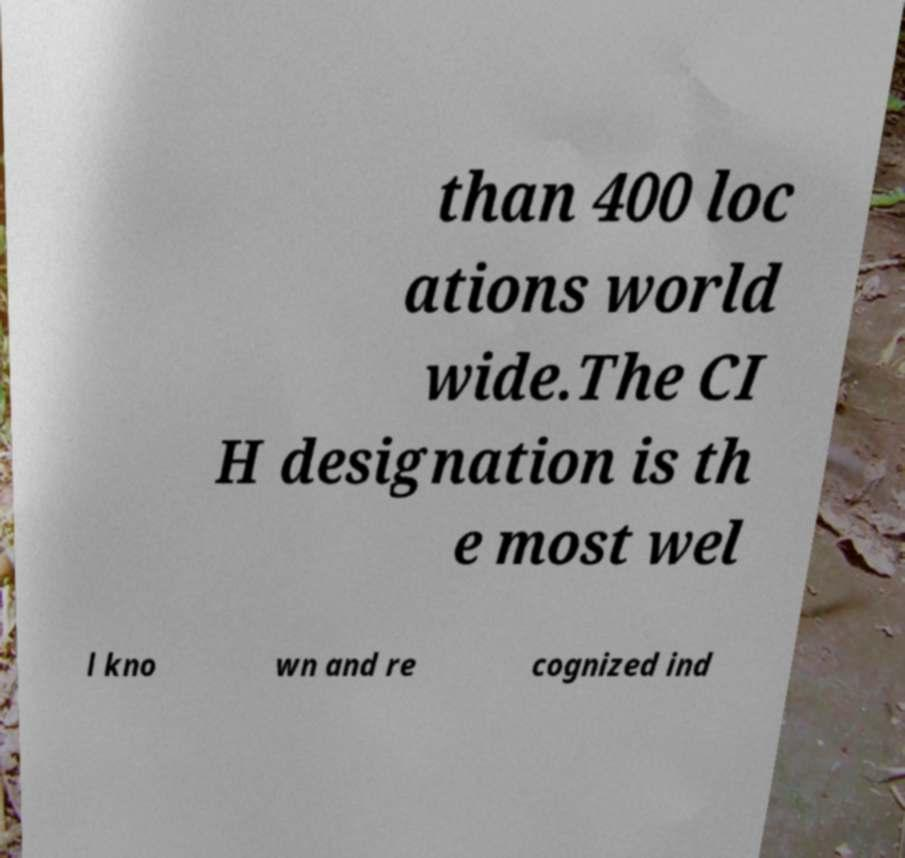Could you extract and type out the text from this image? than 400 loc ations world wide.The CI H designation is th e most wel l kno wn and re cognized ind 